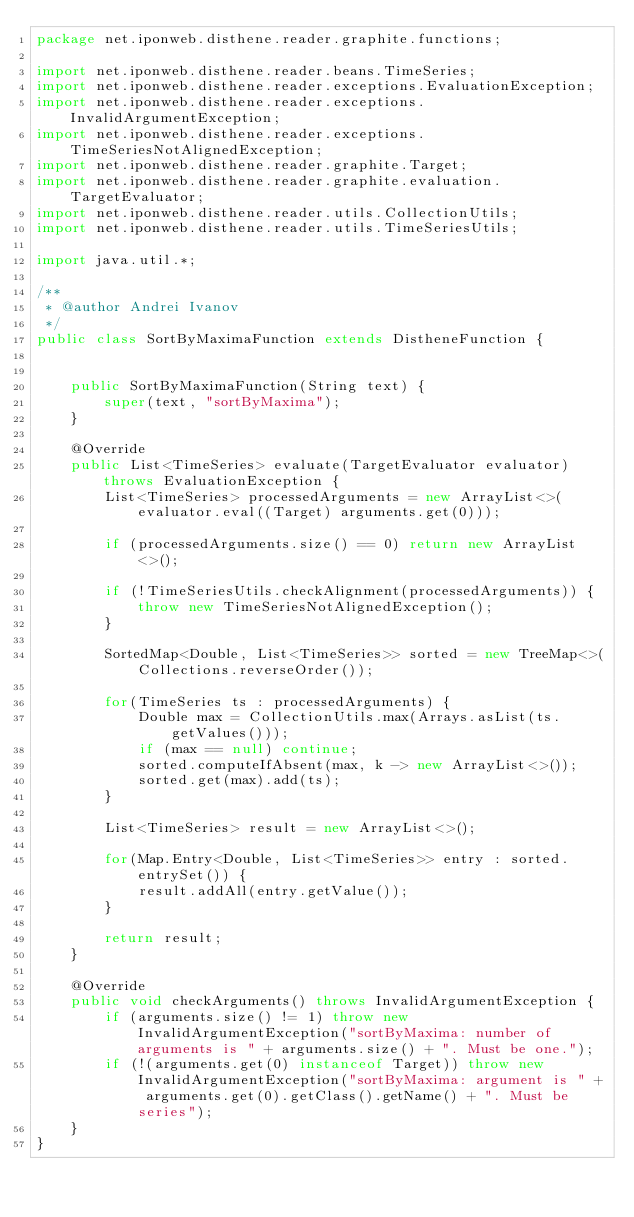Convert code to text. <code><loc_0><loc_0><loc_500><loc_500><_Java_>package net.iponweb.disthene.reader.graphite.functions;

import net.iponweb.disthene.reader.beans.TimeSeries;
import net.iponweb.disthene.reader.exceptions.EvaluationException;
import net.iponweb.disthene.reader.exceptions.InvalidArgumentException;
import net.iponweb.disthene.reader.exceptions.TimeSeriesNotAlignedException;
import net.iponweb.disthene.reader.graphite.Target;
import net.iponweb.disthene.reader.graphite.evaluation.TargetEvaluator;
import net.iponweb.disthene.reader.utils.CollectionUtils;
import net.iponweb.disthene.reader.utils.TimeSeriesUtils;

import java.util.*;

/**
 * @author Andrei Ivanov
 */
public class SortByMaximaFunction extends DistheneFunction {


    public SortByMaximaFunction(String text) {
        super(text, "sortByMaxima");
    }

    @Override
    public List<TimeSeries> evaluate(TargetEvaluator evaluator) throws EvaluationException {
        List<TimeSeries> processedArguments = new ArrayList<>(evaluator.eval((Target) arguments.get(0)));

        if (processedArguments.size() == 0) return new ArrayList<>();

        if (!TimeSeriesUtils.checkAlignment(processedArguments)) {
            throw new TimeSeriesNotAlignedException();
        }

        SortedMap<Double, List<TimeSeries>> sorted = new TreeMap<>(Collections.reverseOrder());

        for(TimeSeries ts : processedArguments) {
            Double max = CollectionUtils.max(Arrays.asList(ts.getValues()));
            if (max == null) continue;
            sorted.computeIfAbsent(max, k -> new ArrayList<>());
            sorted.get(max).add(ts);
        }

        List<TimeSeries> result = new ArrayList<>();

        for(Map.Entry<Double, List<TimeSeries>> entry : sorted.entrySet()) {
            result.addAll(entry.getValue());
        }

        return result;
    }

    @Override
    public void checkArguments() throws InvalidArgumentException {
        if (arguments.size() != 1) throw new InvalidArgumentException("sortByMaxima: number of arguments is " + arguments.size() + ". Must be one.");
        if (!(arguments.get(0) instanceof Target)) throw new InvalidArgumentException("sortByMaxima: argument is " + arguments.get(0).getClass().getName() + ". Must be series");
    }
}</code> 